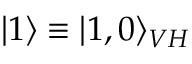Convert formula to latex. <formula><loc_0><loc_0><loc_500><loc_500>| 1 \rangle \equiv | 1 , 0 \rangle _ { V H }</formula> 